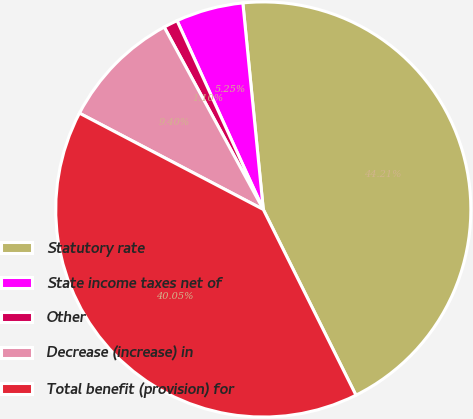Convert chart. <chart><loc_0><loc_0><loc_500><loc_500><pie_chart><fcel>Statutory rate<fcel>State income taxes net of<fcel>Other<fcel>Decrease (increase) in<fcel>Total benefit (provision) for<nl><fcel>44.21%<fcel>5.25%<fcel>1.1%<fcel>9.4%<fcel>40.05%<nl></chart> 